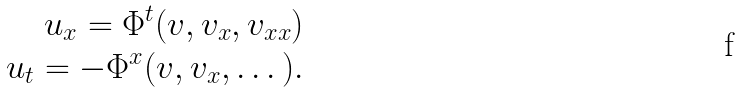Convert formula to latex. <formula><loc_0><loc_0><loc_500><loc_500>u _ { x } = \Phi ^ { t } ( v , v _ { x } , v _ { x x } ) \\ u _ { t } = - \Phi ^ { x } ( v , v _ { x } , \dots ) .</formula> 